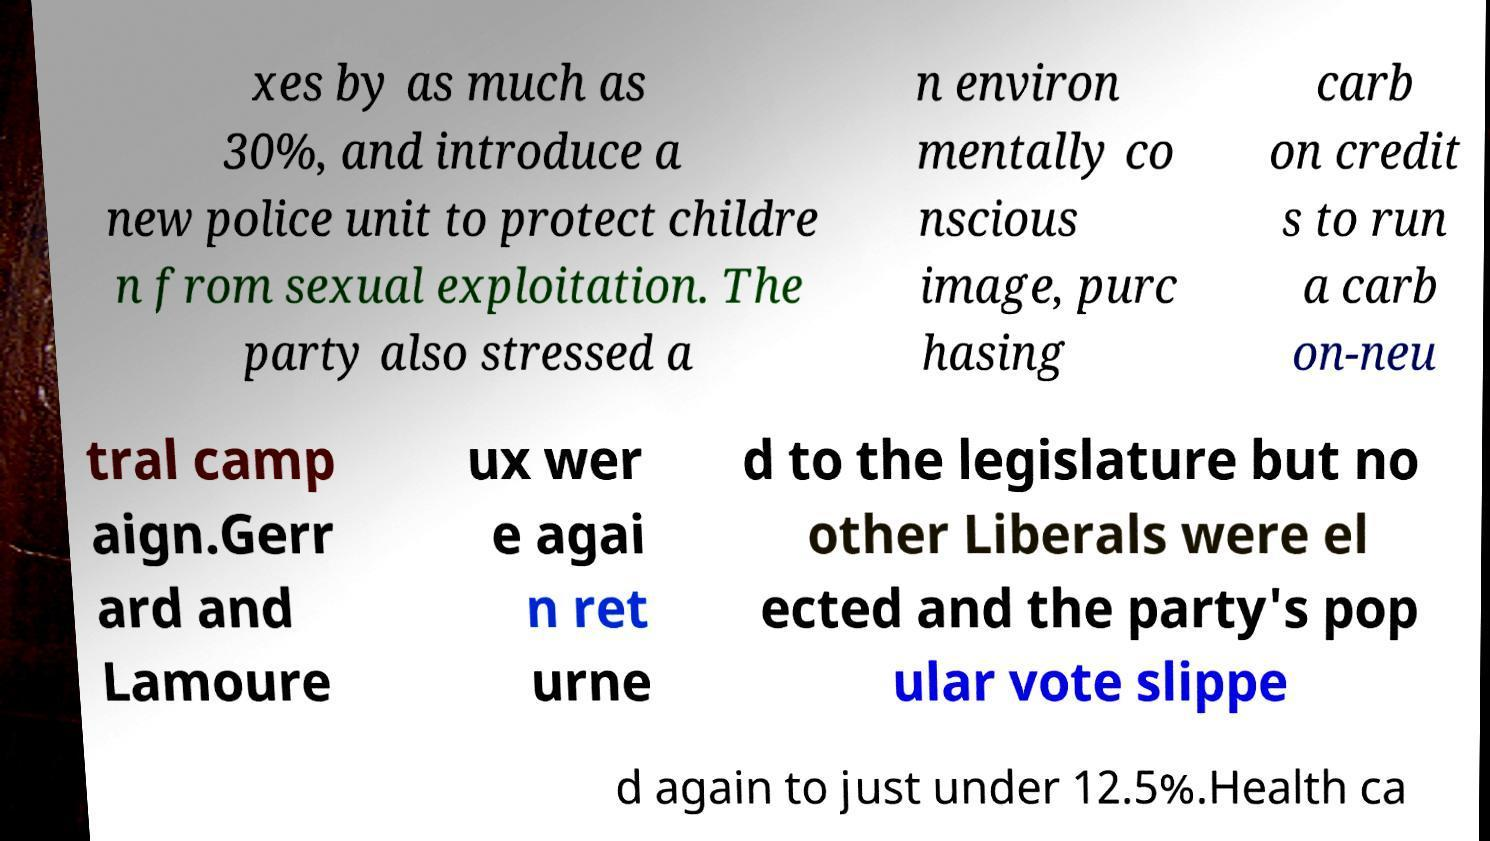Could you extract and type out the text from this image? xes by as much as 30%, and introduce a new police unit to protect childre n from sexual exploitation. The party also stressed a n environ mentally co nscious image, purc hasing carb on credit s to run a carb on-neu tral camp aign.Gerr ard and Lamoure ux wer e agai n ret urne d to the legislature but no other Liberals were el ected and the party's pop ular vote slippe d again to just under 12.5%.Health ca 